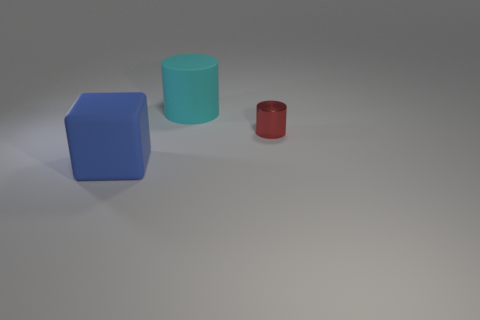Is there any other thing that is the same size as the blue cube?
Your answer should be very brief. Yes. How many objects are either big matte cylinders or tiny blue objects?
Ensure brevity in your answer.  1. What is the shape of the large cyan thing that is the same material as the large blue cube?
Make the answer very short. Cylinder. There is a cylinder that is to the left of the red thing that is right of the blue block; how big is it?
Keep it short and to the point. Large. How many large objects are either shiny objects or cyan rubber things?
Make the answer very short. 1. Do the object that is on the right side of the rubber cylinder and the cylinder behind the red cylinder have the same size?
Your answer should be very brief. No. Is the material of the blue thing the same as the cylinder behind the tiny red metallic object?
Keep it short and to the point. Yes. Are there more cyan things that are behind the large blue rubber cube than blue things behind the small cylinder?
Make the answer very short. Yes. What is the color of the object that is left of the rubber thing on the right side of the blue matte block?
Your answer should be very brief. Blue. What number of spheres are tiny shiny things or big objects?
Your response must be concise. 0. 